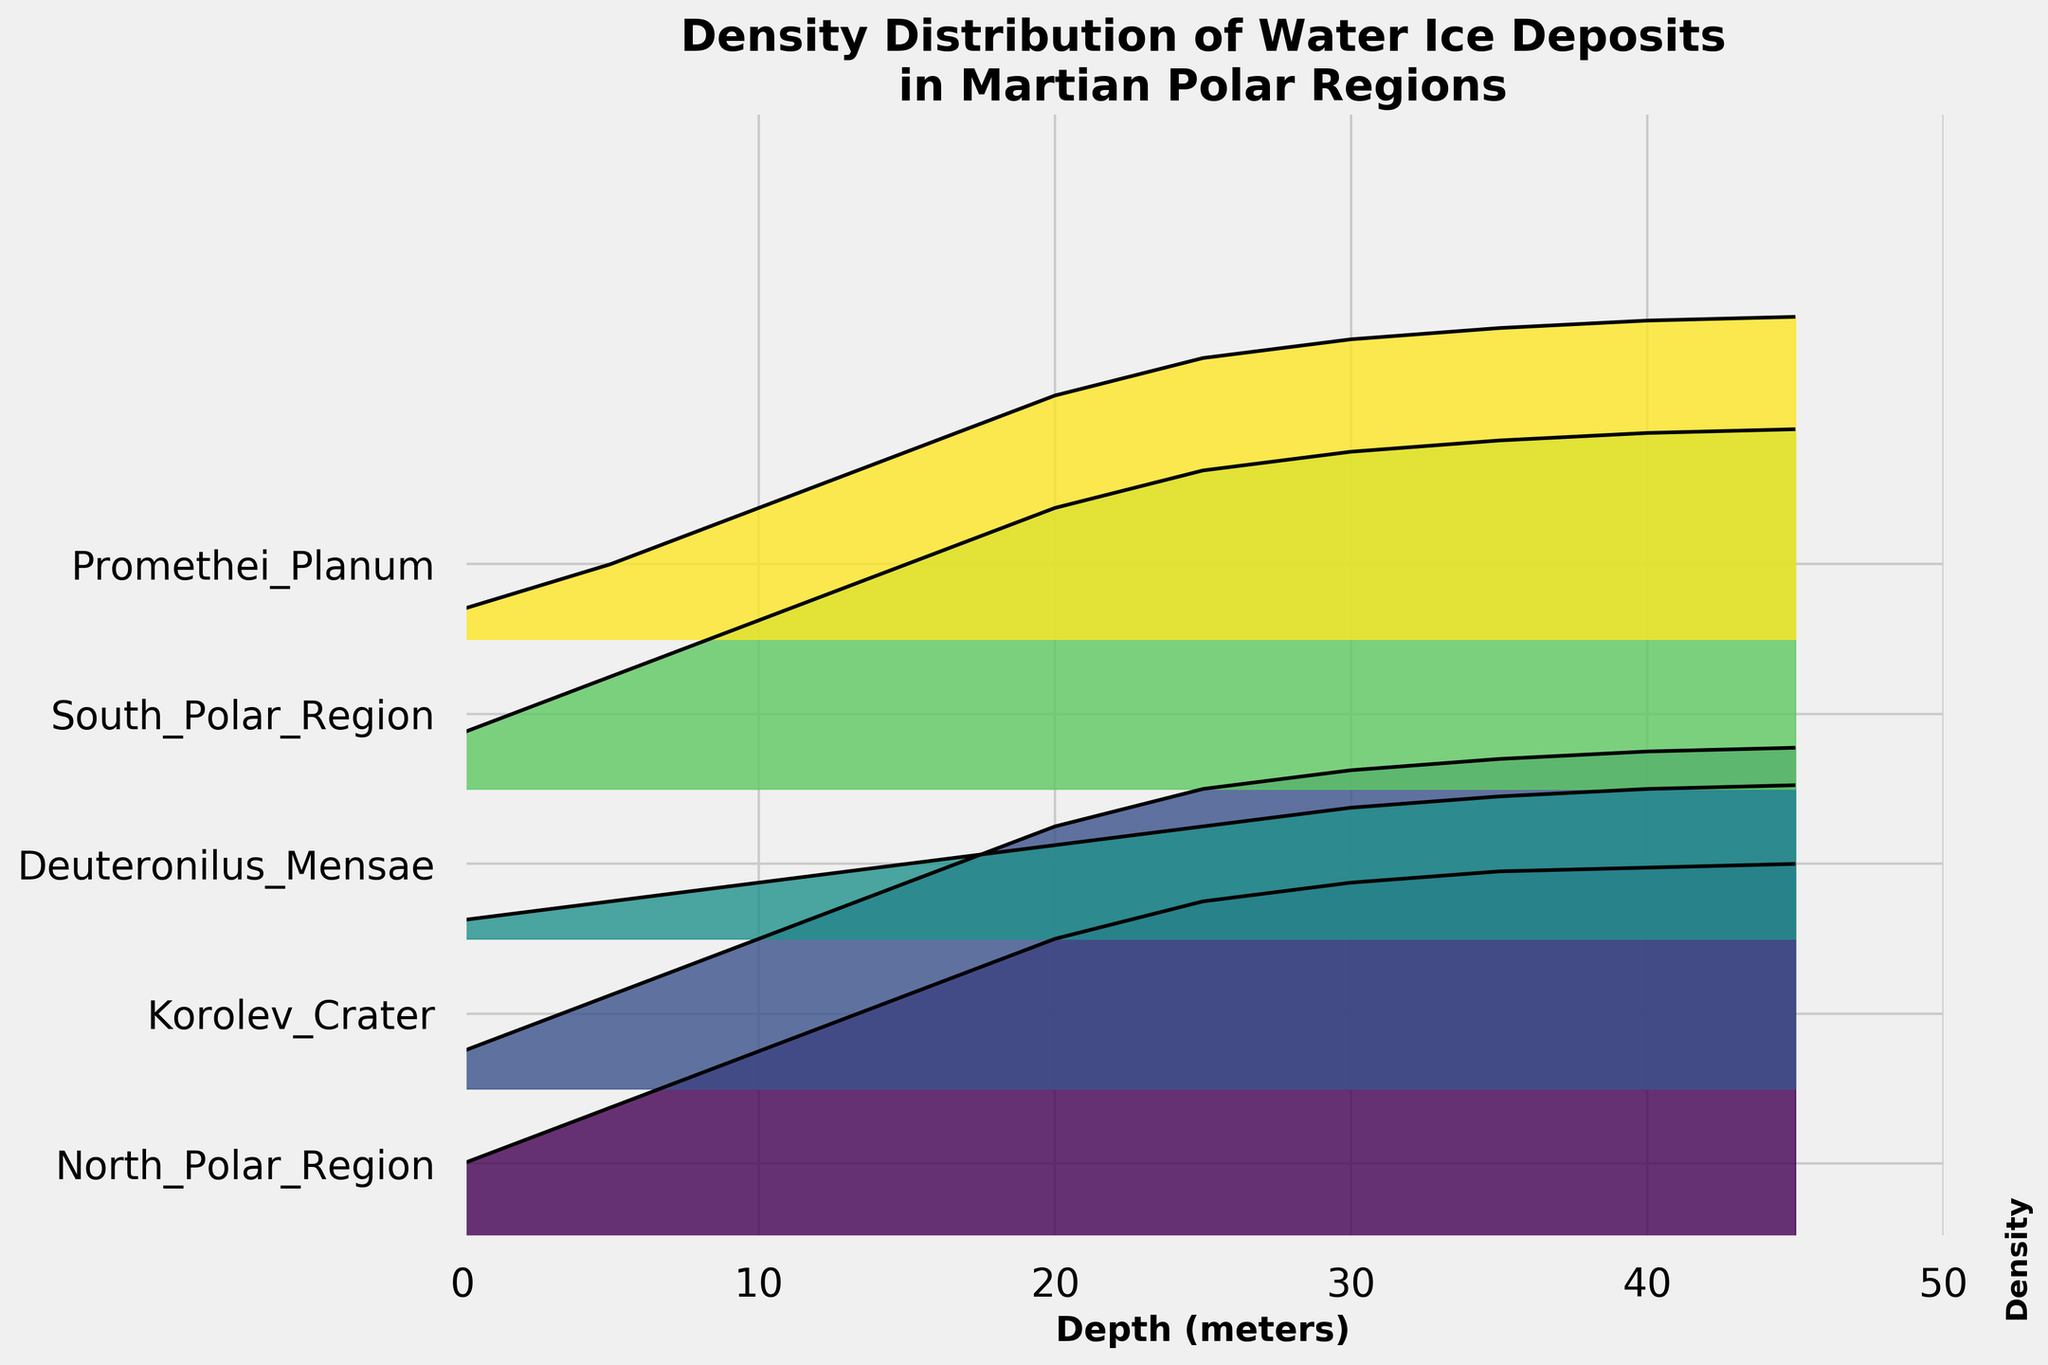What is the title of the figure? The title is typically located at the top of the figure and provides a brief description of the content. In this case, it reads, "Density Distribution of Water Ice Deposits in Martian Polar Regions."
Answer: Density Distribution of Water Ice Deposits in Martian Polar Regions Which region shows the highest density of water ice deposits at a depth of 10 meters? To determine this, locate the depth of 10 meters on the x-axis, then trace upward to find the highest line. The highest density corresponds to the North Polar Region.
Answer: North Polar Region What is the color used to represent Deuteronilus Mensae? The color used to represent each region is visible in the filled area of the ridgeline. Deuteronilus Mensae is represented by a distinct color, which can be seen from the lines and shades in their section.
Answer: A light blue/greenish color How does the density of water ice deposits in the South Polar Region change from 0 to 40 meters? Starting from the x-axis at 0 meters and moving rightward, observe the rising curve for the South Polar Region. It steadily increases, reaching higher density values as the depth increases to 40 meters.
Answer: It increases steadily At what depth does Korolev Crater reach its highest density? Find the peak point in the Korolev Crater's ridgeline then trace this peak down perpendicular to the x-axis to read the corresponding depth value, which is at 40 meters.
Answer: 40 meters Which region has the lowest density at a depth of 25 meters? Locate 25 meters on the x-axis, and compare the heights of the ridgelines for each region at this depth. The lowest line corresponds to Deuteronilus Mensae.
Answer: Deuteronilus Mensae How much higher is the density of the North Polar Region compared to Promethei Planum at 10 meters? At 10 meters, read the density values for both regions. The North Polar Region has a density of 0.5, and Promethei Planum has 0.35. Subtract the density of Promethei Planum from the North Polar Region to find the difference (0.5 - 0.35).
Answer: 0.15 What is the trend of density distribution with increasing depth in Promethei Planum? Trace the Promethei Planum line from 0 to 45 meters. It shows a consistent and gradual increase in density, implying a positive correlation with depth.
Answer: It increases gradually Which region has a density value closest to 0.8 at any depth? Scan the figure for the ridgeline that intersects the density value of 0.8. North Polar Region notably intersects closest to this value at around 20-25 meters depth.
Answer: North Polar Region 